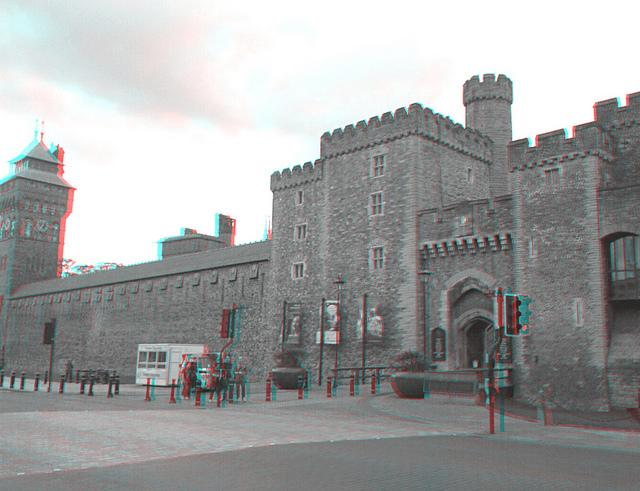What sort of building stand in could this building substitute for in a movie?

Choices:
A) nunnery
B) castle
C) 711
D) taxi stand castle 